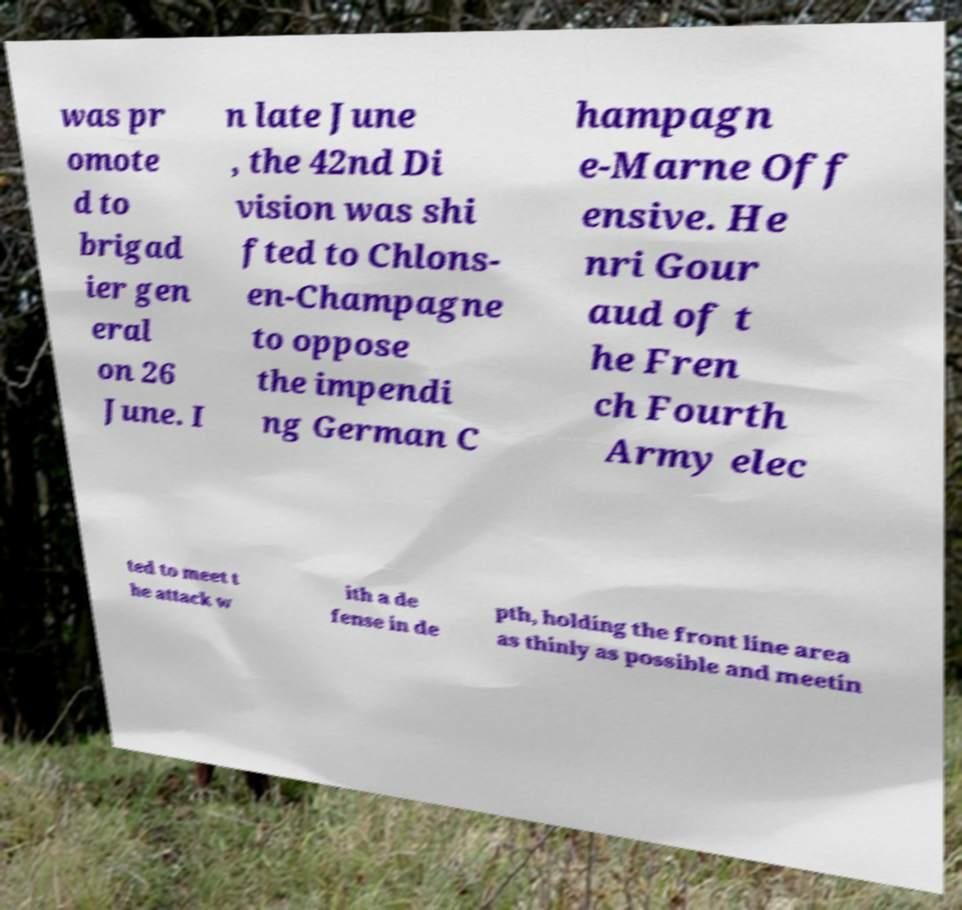Please identify and transcribe the text found in this image. was pr omote d to brigad ier gen eral on 26 June. I n late June , the 42nd Di vision was shi fted to Chlons- en-Champagne to oppose the impendi ng German C hampagn e-Marne Off ensive. He nri Gour aud of t he Fren ch Fourth Army elec ted to meet t he attack w ith a de fense in de pth, holding the front line area as thinly as possible and meetin 